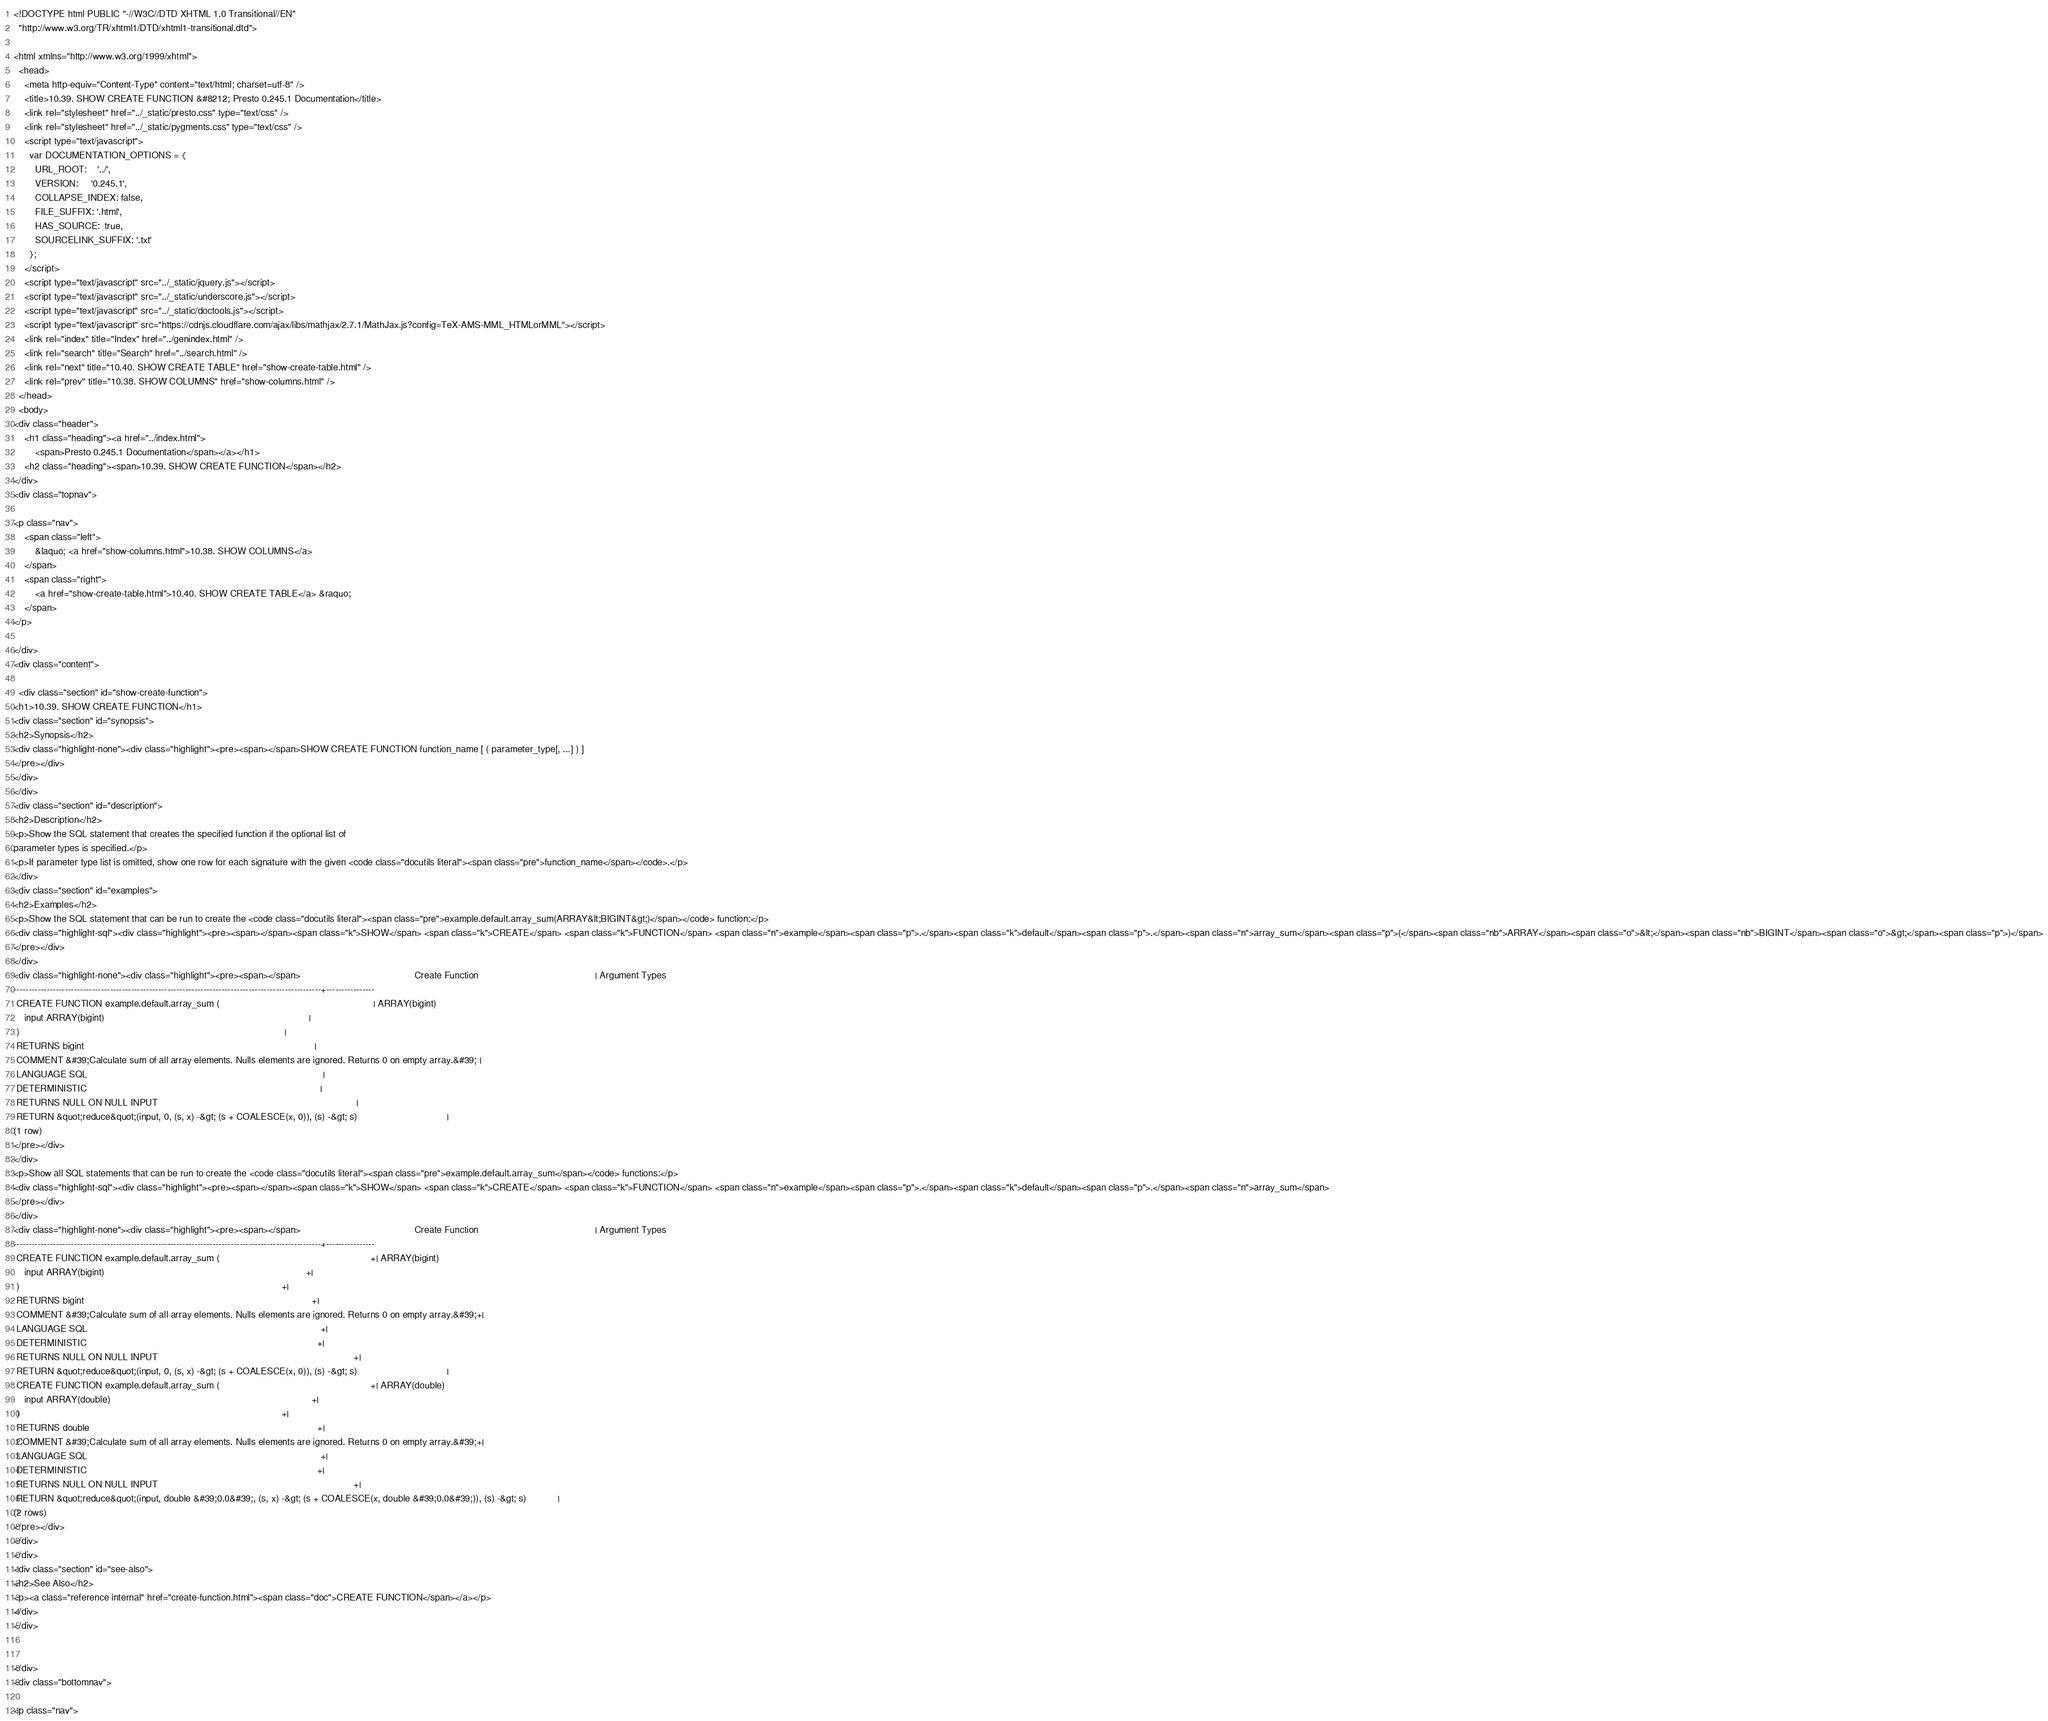Convert code to text. <code><loc_0><loc_0><loc_500><loc_500><_HTML_>
<!DOCTYPE html PUBLIC "-//W3C//DTD XHTML 1.0 Transitional//EN"
  "http://www.w3.org/TR/xhtml1/DTD/xhtml1-transitional.dtd">

<html xmlns="http://www.w3.org/1999/xhtml">
  <head>
    <meta http-equiv="Content-Type" content="text/html; charset=utf-8" />
    <title>10.39. SHOW CREATE FUNCTION &#8212; Presto 0.245.1 Documentation</title>
    <link rel="stylesheet" href="../_static/presto.css" type="text/css" />
    <link rel="stylesheet" href="../_static/pygments.css" type="text/css" />
    <script type="text/javascript">
      var DOCUMENTATION_OPTIONS = {
        URL_ROOT:    '../',
        VERSION:     '0.245.1',
        COLLAPSE_INDEX: false,
        FILE_SUFFIX: '.html',
        HAS_SOURCE:  true,
        SOURCELINK_SUFFIX: '.txt'
      };
    </script>
    <script type="text/javascript" src="../_static/jquery.js"></script>
    <script type="text/javascript" src="../_static/underscore.js"></script>
    <script type="text/javascript" src="../_static/doctools.js"></script>
    <script type="text/javascript" src="https://cdnjs.cloudflare.com/ajax/libs/mathjax/2.7.1/MathJax.js?config=TeX-AMS-MML_HTMLorMML"></script>
    <link rel="index" title="Index" href="../genindex.html" />
    <link rel="search" title="Search" href="../search.html" />
    <link rel="next" title="10.40. SHOW CREATE TABLE" href="show-create-table.html" />
    <link rel="prev" title="10.38. SHOW COLUMNS" href="show-columns.html" /> 
  </head>
  <body>
<div class="header">
    <h1 class="heading"><a href="../index.html">
        <span>Presto 0.245.1 Documentation</span></a></h1>
    <h2 class="heading"><span>10.39. SHOW CREATE FUNCTION</span></h2>
</div>
<div class="topnav">
    
<p class="nav">
    <span class="left">
        &laquo; <a href="show-columns.html">10.38. SHOW COLUMNS</a>
    </span>
    <span class="right">
        <a href="show-create-table.html">10.40. SHOW CREATE TABLE</a> &raquo;
    </span>
</p>

</div>
<div class="content">
    
  <div class="section" id="show-create-function">
<h1>10.39. SHOW CREATE FUNCTION</h1>
<div class="section" id="synopsis">
<h2>Synopsis</h2>
<div class="highlight-none"><div class="highlight"><pre><span></span>SHOW CREATE FUNCTION function_name [ ( parameter_type[, ...] ) ]
</pre></div>
</div>
</div>
<div class="section" id="description">
<h2>Description</h2>
<p>Show the SQL statement that creates the specified function if the optional list of
parameter types is specified.</p>
<p>If parameter type list is omitted, show one row for each signature with the given <code class="docutils literal"><span class="pre">function_name</span></code>.</p>
</div>
<div class="section" id="examples">
<h2>Examples</h2>
<p>Show the SQL statement that can be run to create the <code class="docutils literal"><span class="pre">example.default.array_sum(ARRAY&lt;BIGINT&gt;)</span></code> function:</p>
<div class="highlight-sql"><div class="highlight"><pre><span></span><span class="k">SHOW</span> <span class="k">CREATE</span> <span class="k">FUNCTION</span> <span class="n">example</span><span class="p">.</span><span class="k">default</span><span class="p">.</span><span class="n">array_sum</span><span class="p">(</span><span class="nb">ARRAY</span><span class="o">&lt;</span><span class="nb">BIGINT</span><span class="o">&gt;</span><span class="p">)</span>
</pre></div>
</div>
<div class="highlight-none"><div class="highlight"><pre><span></span>                                           Create Function                                            | Argument Types
------------------------------------------------------------------------------------------------------+----------------
 CREATE FUNCTION example.default.array_sum (                                                          | ARRAY(bigint)
    input ARRAY(bigint)                                                                             |
 )                                                                                                    |
 RETURNS bigint                                                                                       |
 COMMENT &#39;Calculate sum of all array elements. Nulls elements are ignored. Returns 0 on empty array.&#39; |
 LANGUAGE SQL                                                                                         |
 DETERMINISTIC                                                                                        |
 RETURNS NULL ON NULL INPUT                                                                           |
 RETURN &quot;reduce&quot;(input, 0, (s, x) -&gt; (s + COALESCE(x, 0)), (s) -&gt; s)                                  |
(1 row)
</pre></div>
</div>
<p>Show all SQL statements that can be run to create the <code class="docutils literal"><span class="pre">example.default.array_sum</span></code> functions:</p>
<div class="highlight-sql"><div class="highlight"><pre><span></span><span class="k">SHOW</span> <span class="k">CREATE</span> <span class="k">FUNCTION</span> <span class="n">example</span><span class="p">.</span><span class="k">default</span><span class="p">.</span><span class="n">array_sum</span>
</pre></div>
</div>
<div class="highlight-none"><div class="highlight"><pre><span></span>                                           Create Function                                            | Argument Types
------------------------------------------------------------------------------------------------------+----------------
 CREATE FUNCTION example.default.array_sum (                                                         +| ARRAY(bigint)
    input ARRAY(bigint)                                                                            +|
 )                                                                                                   +|
 RETURNS bigint                                                                                      +|
 COMMENT &#39;Calculate sum of all array elements. Nulls elements are ignored. Returns 0 on empty array.&#39;+|
 LANGUAGE SQL                                                                                        +|
 DETERMINISTIC                                                                                       +|
 RETURNS NULL ON NULL INPUT                                                                          +|
 RETURN &quot;reduce&quot;(input, 0, (s, x) -&gt; (s + COALESCE(x, 0)), (s) -&gt; s)                                  |
 CREATE FUNCTION example.default.array_sum (                                                         +| ARRAY(double)
    input ARRAY(double)                                                                            +|
 )                                                                                                   +|
 RETURNS double                                                                                      +|
 COMMENT &#39;Calculate sum of all array elements. Nulls elements are ignored. Returns 0 on empty array.&#39;+|
 LANGUAGE SQL                                                                                        +|
 DETERMINISTIC                                                                                       +|
 RETURNS NULL ON NULL INPUT                                                                          +|
 RETURN &quot;reduce&quot;(input, double &#39;0.0&#39;, (s, x) -&gt; (s + COALESCE(x, double &#39;0.0&#39;)), (s) -&gt; s)            |
(2 rows)
</pre></div>
</div>
</div>
<div class="section" id="see-also">
<h2>See Also</h2>
<p><a class="reference internal" href="create-function.html"><span class="doc">CREATE FUNCTION</span></a></p>
</div>
</div>


</div>
<div class="bottomnav">
    
<p class="nav"></code> 